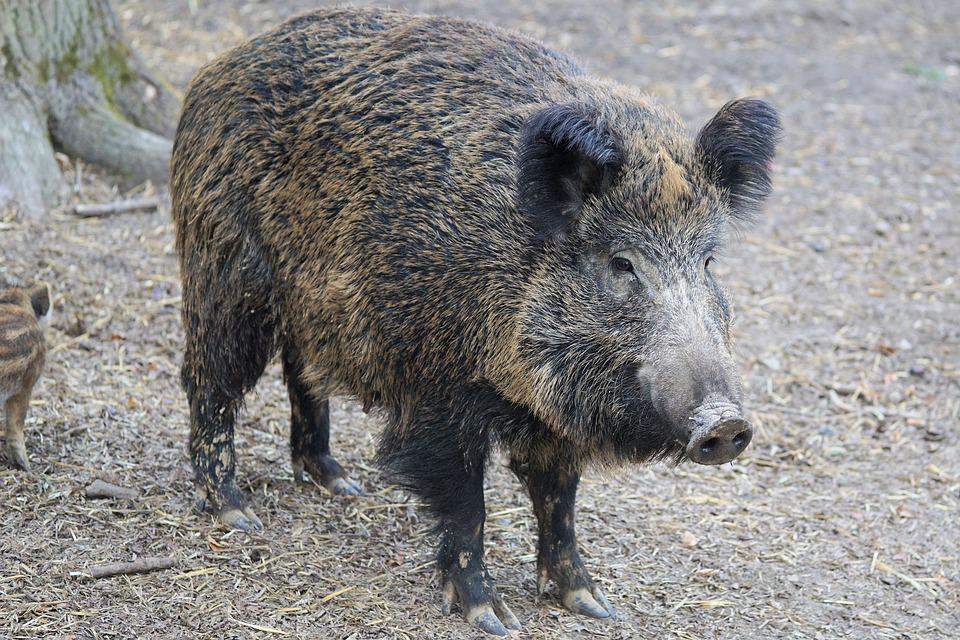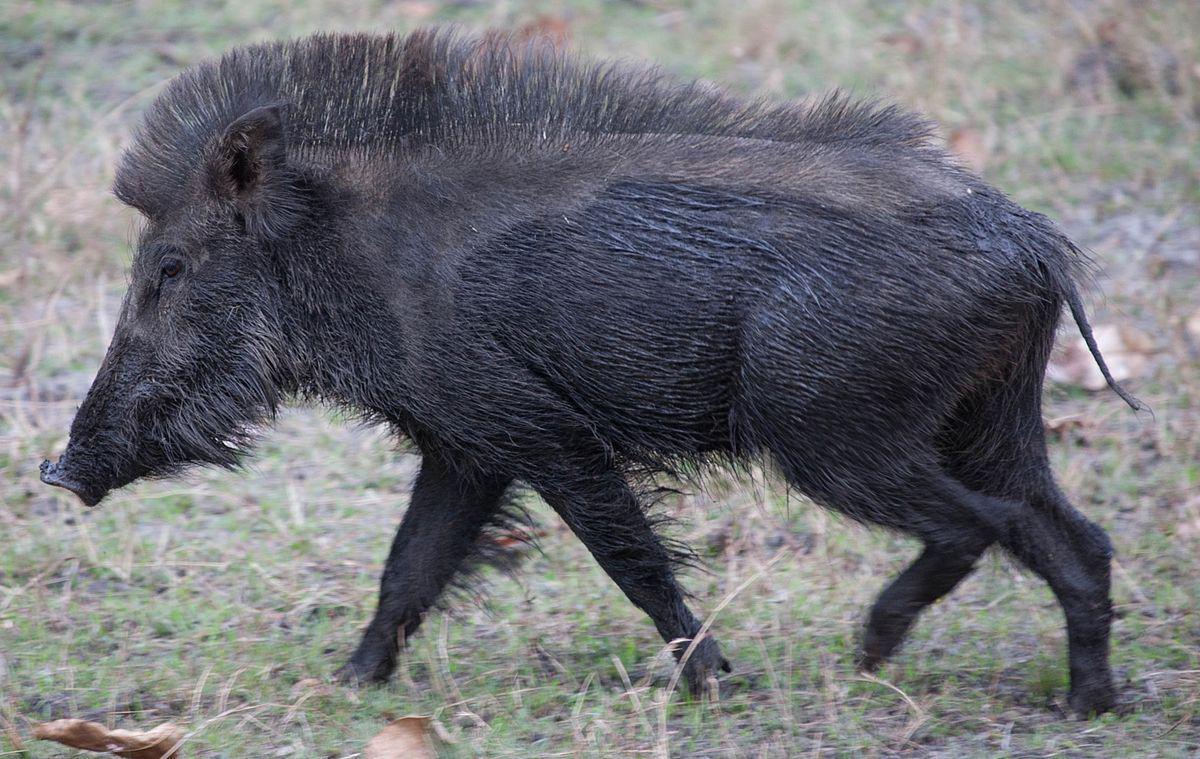The first image is the image on the left, the second image is the image on the right. Evaluate the accuracy of this statement regarding the images: "The animal in the image on the right is facing right.". Is it true? Answer yes or no. No. 